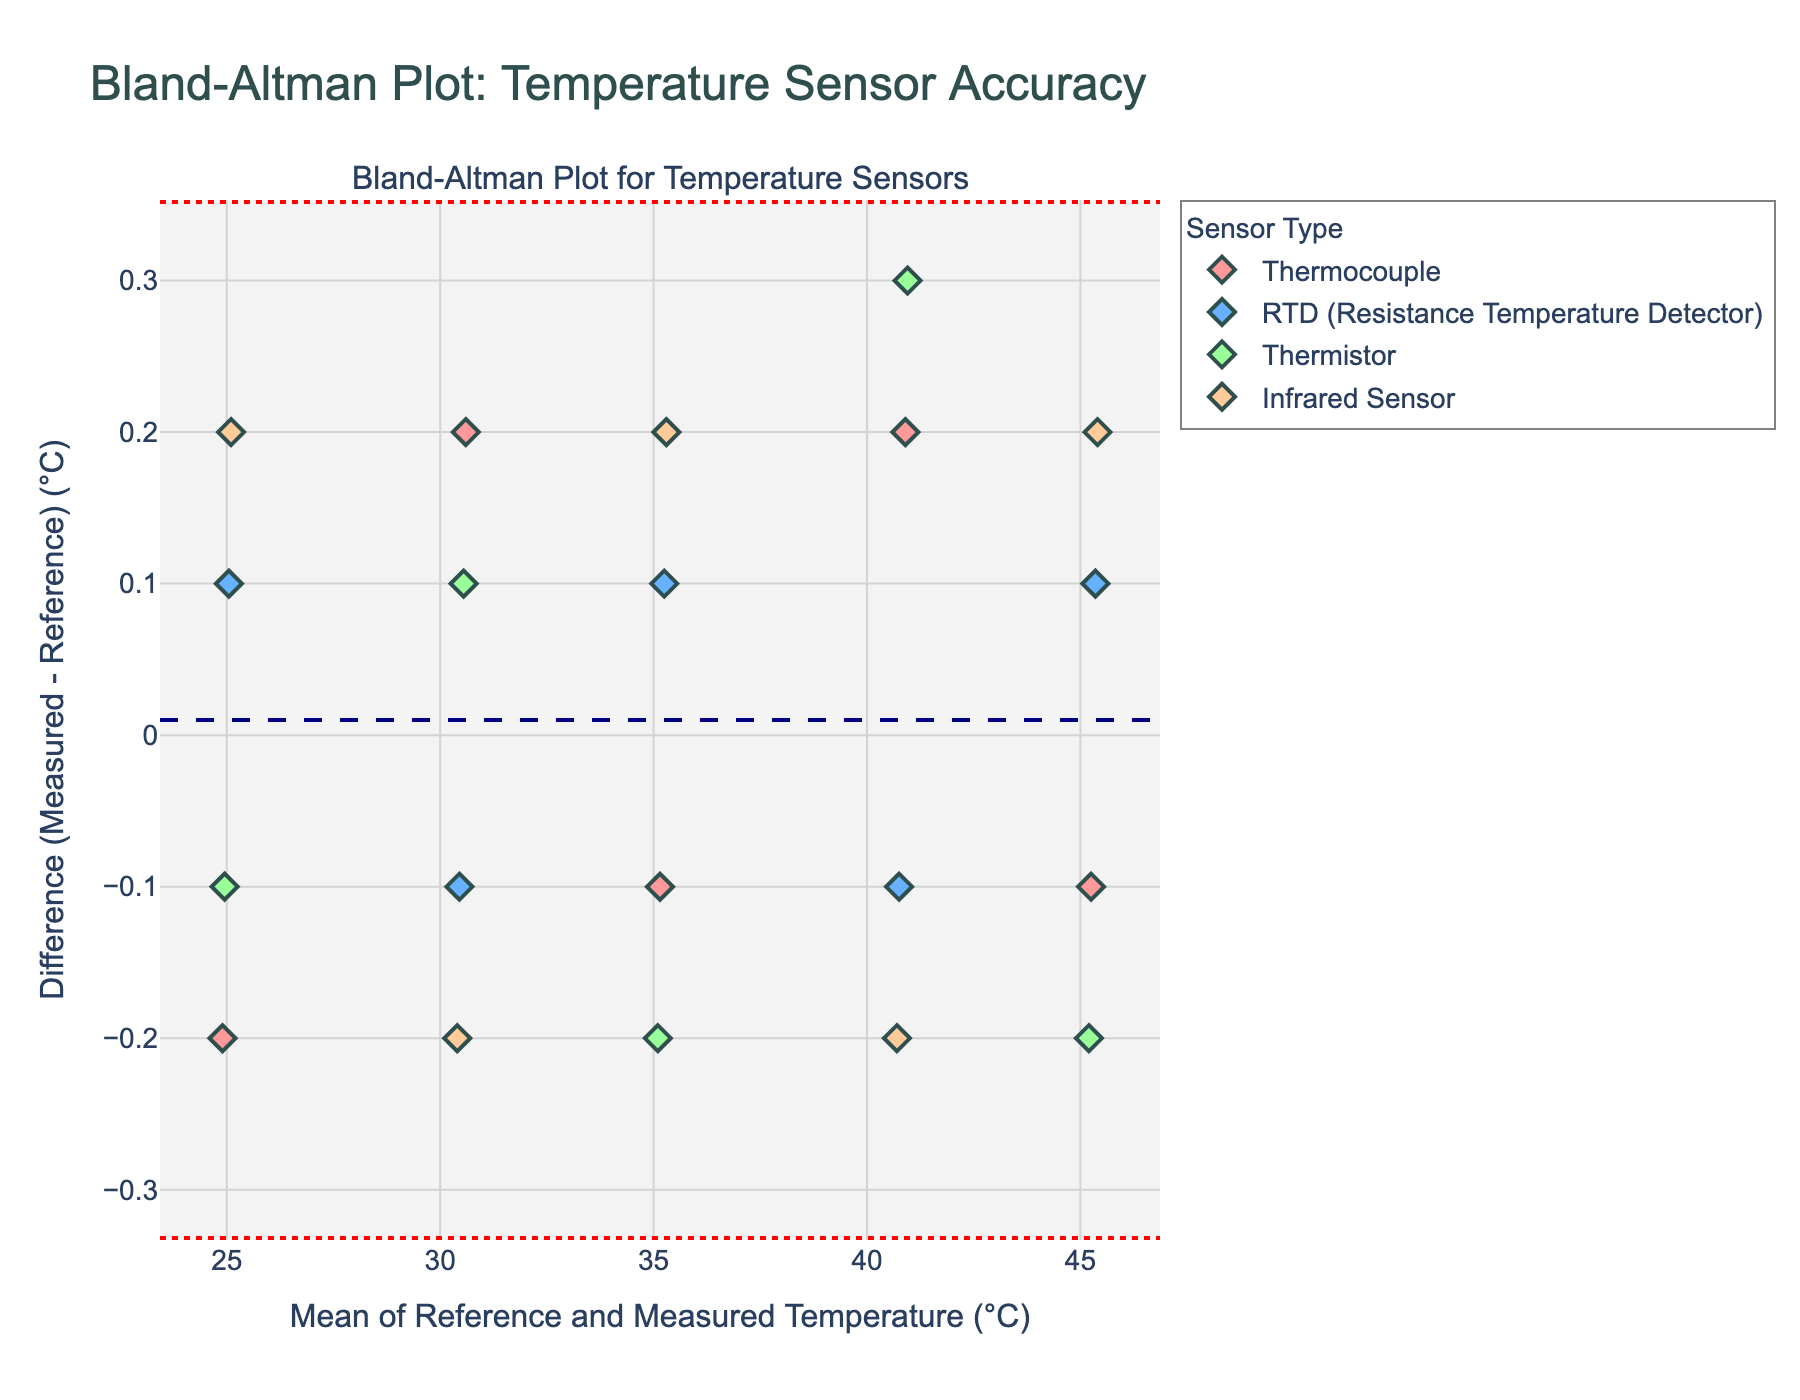What is the title of the figure? The title is usually displayed at the top of the figure. In this case, it reads "Bland-Altman Plot: Temperature Sensor Accuracy".
Answer: Bland-Altman Plot: Temperature Sensor Accuracy How many temperature sensor types are represented in the plot? In the legend or the markers’ labels, different sensor types are shown. We can count four categories: Thermocouple, RTD (Resistance Temperature Detector), Thermistor, and Infrared Sensor.
Answer: Four What does the x-axis represent in the figure? The x-axis typically has a label, which in this case is "Mean of Reference and Measured Temperature (°C)".
Answer: Mean of Reference and Measured Temperature (°C) Which sensor type has the largest mean difference from the reference temperature? Look for consistently higher or lower y-values on the plot, particularly the mean line for each sensor. By examining the scatter plots, the Infrared Sensor generally seems to have larger deviations.
Answer: Infrared Sensor What are the units for the y-axis? The y-axis label shows units. Here it reads "Difference (Measured - Reference) (°C)", indicating degrees Celsius.
Answer: Degrees Celsius (°C) Compare the variability in measurements between Thermistor and RTD sensors. Which one shows more spread? Analyze the spread of data points along the y-axis for both categories. Broader spread indicates higher variability. Thermistor shows more variability compared to RTD sensors, as indicated by a wider scatter in y values.
Answer: Thermistor What are the values of the upper and lower limits of agreement (LoA) shown on the plot? The plot has dashed lines for these limits. By identifying their y-values, we find the upper limit around +0.3°C and the lower limit around -0.3°C, approximately.
Answer: +0.3°C and -0.3°C Does the RTD sensor generally show a positive or negative difference compared to the reference temperature? Examine the position of RTD sensor data points relative to the zero line on the y-axis. The RTD sensor measurements mostly hover around zero but show a slight positive difference.
Answer: Slightly positive What is the mean difference of all sensors from the reference temperature? The mean difference line spans horizontally across the plot. The y-value of this line provides the mean difference, which is approximately 0.
Answer: Approximately 0 How do the Infrared Sensor’s measurements vary across different mean temperatures? Examine the Infrared Sensor data points' positions and their distribution along the x-axis. They show larger deviations at higher mean temperatures but relatively consistent across the range.
Answer: Larger deviations at higher mean temperatures 